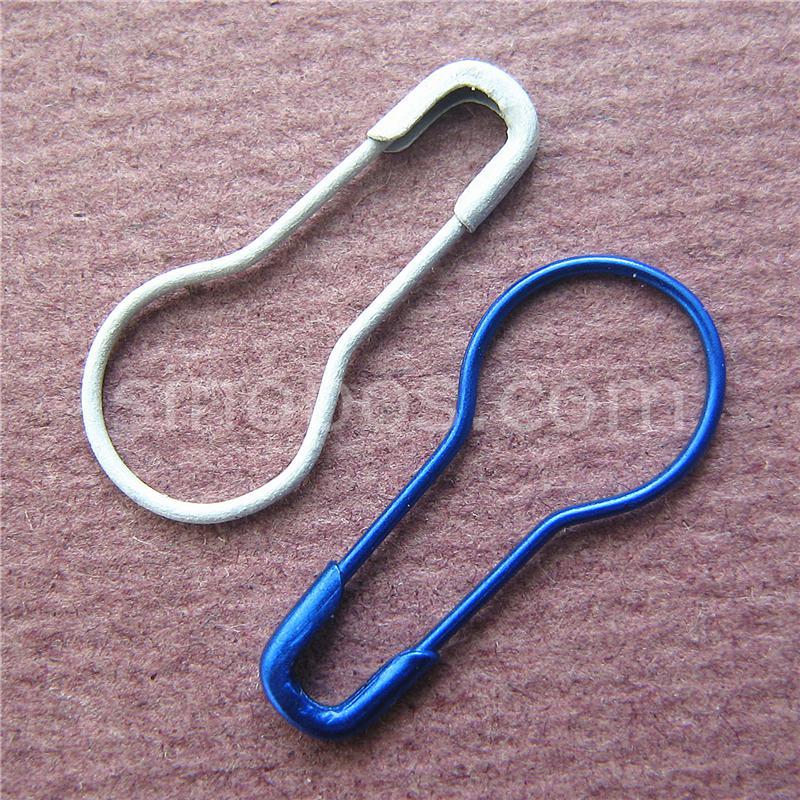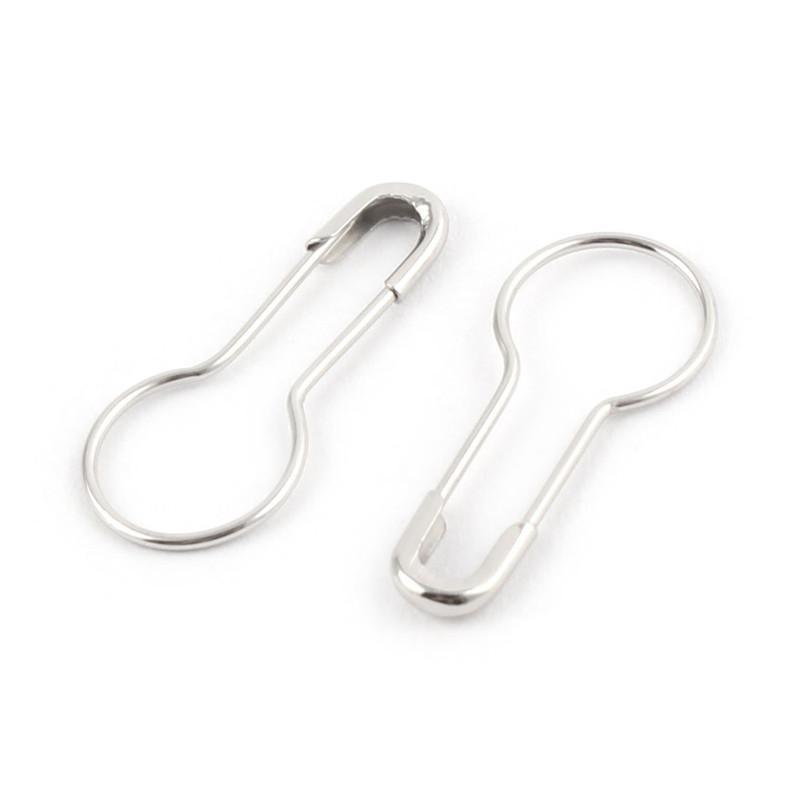The first image is the image on the left, the second image is the image on the right. Considering the images on both sides, is "There are more pins in the image on the right than in the image on the left." valid? Answer yes or no. No. The first image is the image on the left, the second image is the image on the right. Considering the images on both sides, is "All pins in each image are the same color and all have a large circular end opposite the clasp end." valid? Answer yes or no. No. 